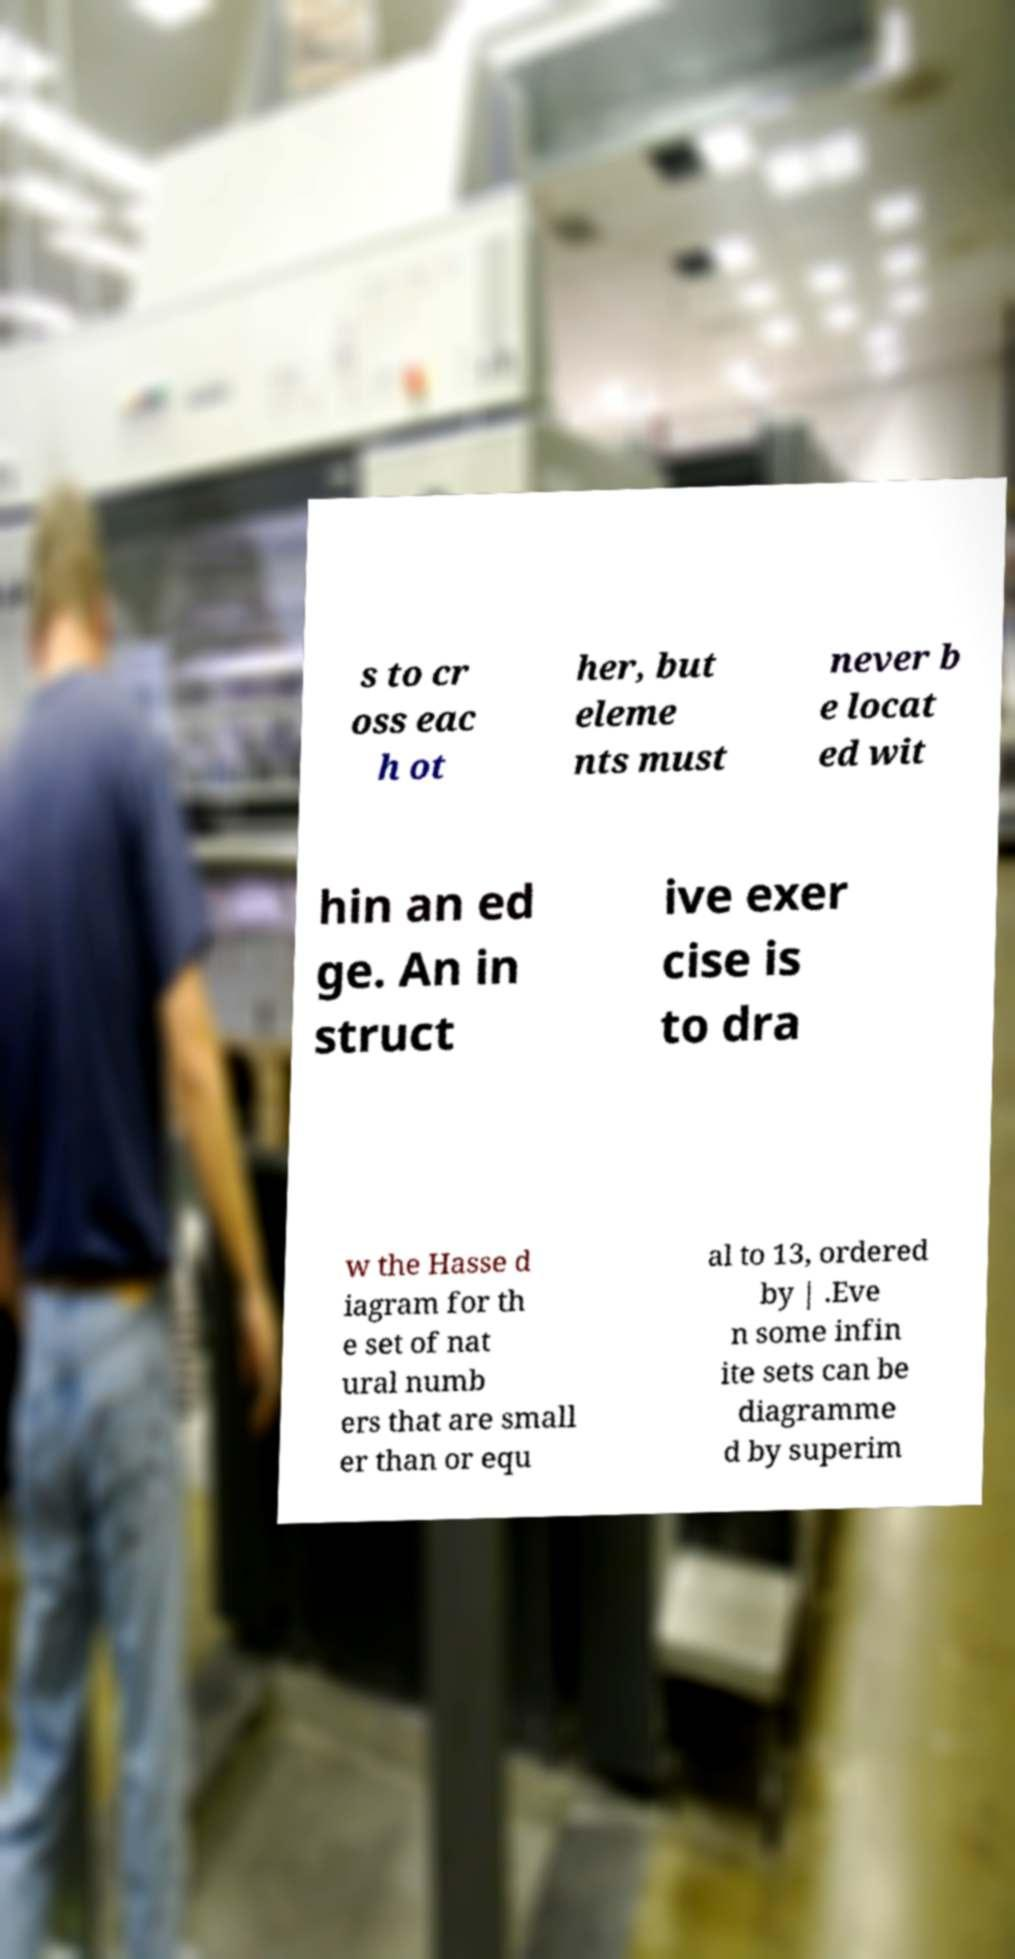Could you assist in decoding the text presented in this image and type it out clearly? s to cr oss eac h ot her, but eleme nts must never b e locat ed wit hin an ed ge. An in struct ive exer cise is to dra w the Hasse d iagram for th e set of nat ural numb ers that are small er than or equ al to 13, ordered by | .Eve n some infin ite sets can be diagramme d by superim 